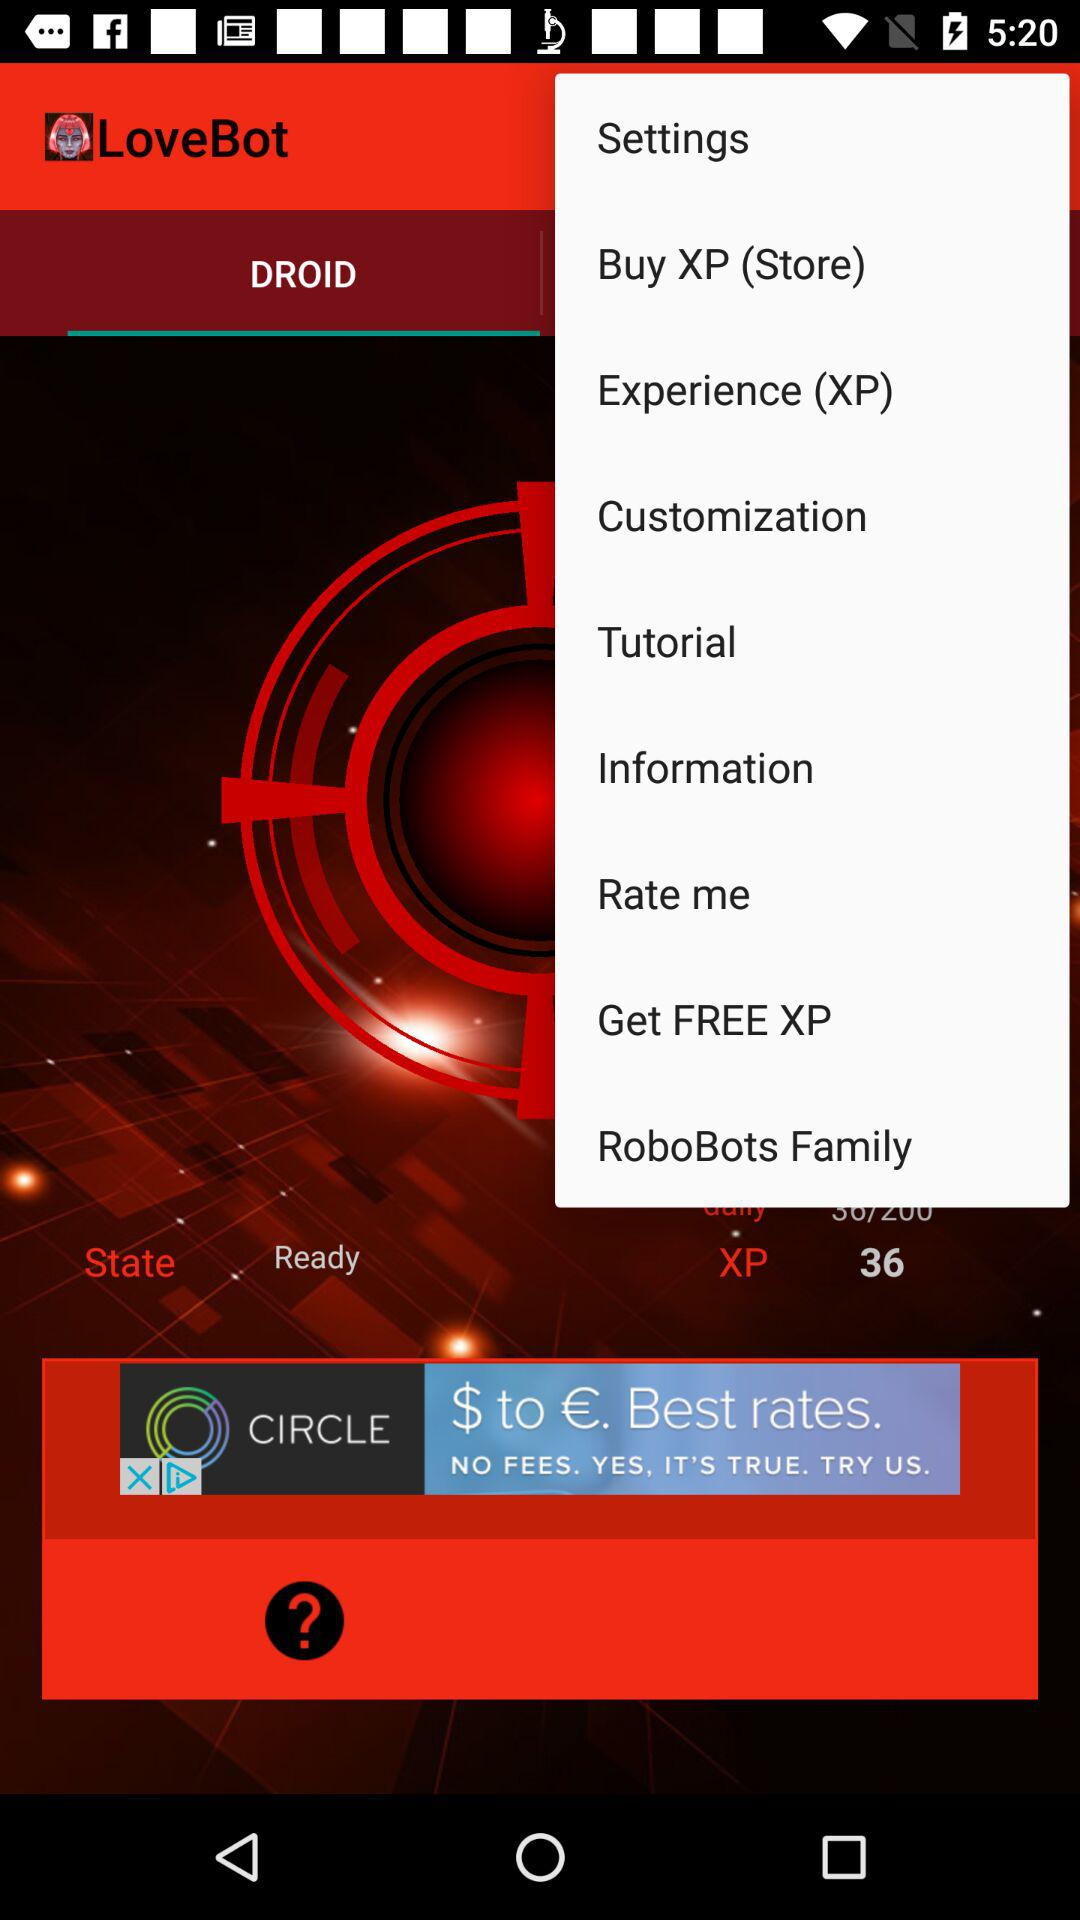How much XP does the player have?
Answer the question using a single word or phrase. 36 